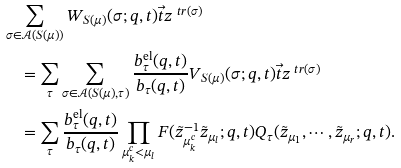<formula> <loc_0><loc_0><loc_500><loc_500>& \sum _ { \sigma \in \mathcal { A } ( S ( \mu ) ) } W _ { S ( \mu ) } ( \sigma ; q , t ) \vec { t } z ^ { \ t r ( \sigma ) } \\ & \quad = \sum _ { \tau } \sum _ { \sigma \in \mathcal { A } ( S ( \mu ) , \tau ) } \frac { b _ { \tau } ^ { \text {el} } ( q , t ) } { b _ { \tau } ( q , t ) } V _ { S ( \mu ) } ( \sigma ; q , t ) \vec { t } z ^ { \ t r ( \sigma ) } \\ & \quad = \sum _ { \tau } \frac { b _ { \tau } ^ { \text {el} } ( q , t ) } { b _ { \tau } ( q , t ) } \prod _ { \mu ^ { c } _ { k } < \mu _ { l } } F ( \tilde { z } _ { \mu ^ { c } _ { k } } ^ { - 1 } \tilde { z } _ { \mu _ { l } } ; q , t ) Q _ { \tau } ( \tilde { z } _ { \mu _ { 1 } } , \cdots , \tilde { z } _ { \mu _ { r } } ; q , t ) .</formula> 